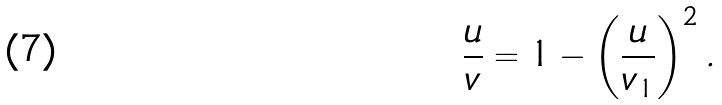Convert formula to latex. <formula><loc_0><loc_0><loc_500><loc_500>\frac { u } { v } = 1 - \left ( \frac { u } { v _ { 1 } } \right ) ^ { 2 } .</formula> 